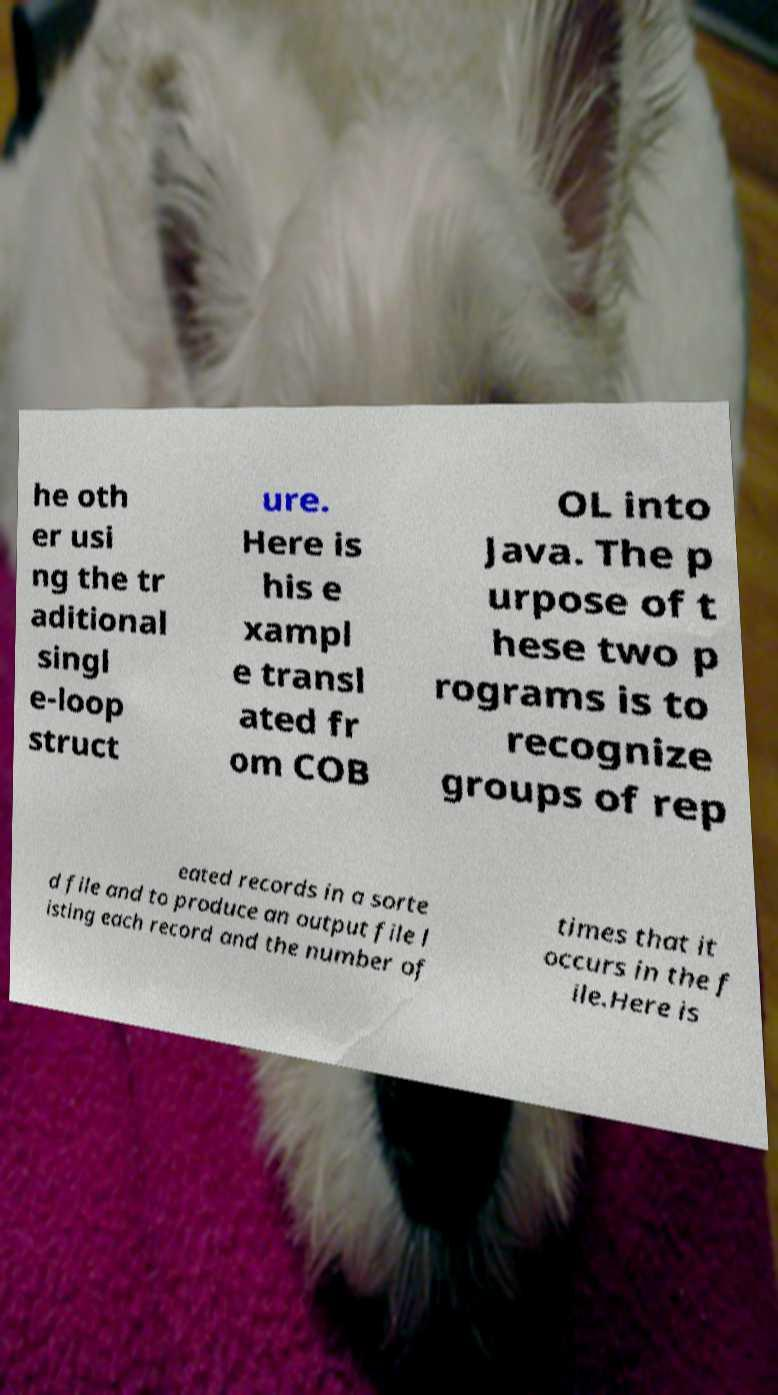Could you assist in decoding the text presented in this image and type it out clearly? he oth er usi ng the tr aditional singl e-loop struct ure. Here is his e xampl e transl ated fr om COB OL into Java. The p urpose of t hese two p rograms is to recognize groups of rep eated records in a sorte d file and to produce an output file l isting each record and the number of times that it occurs in the f ile.Here is 